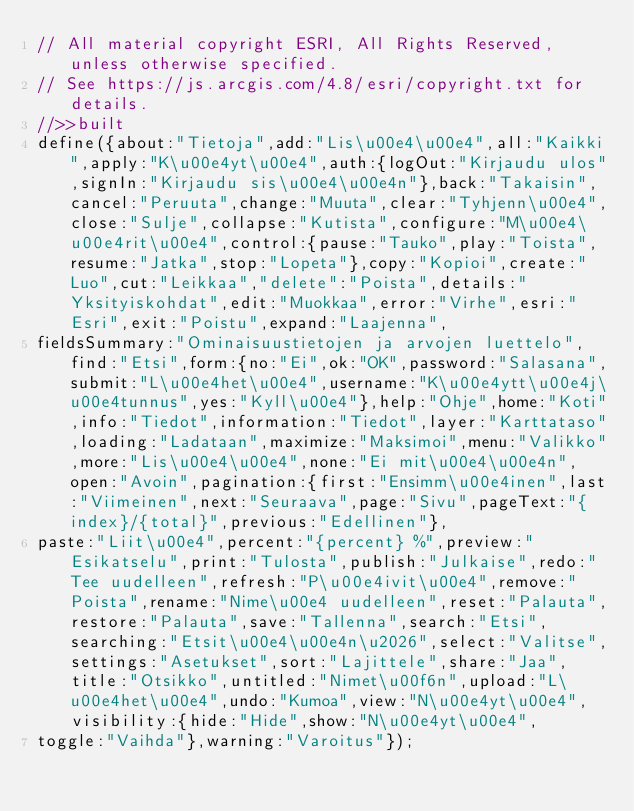<code> <loc_0><loc_0><loc_500><loc_500><_JavaScript_>// All material copyright ESRI, All Rights Reserved, unless otherwise specified.
// See https://js.arcgis.com/4.8/esri/copyright.txt for details.
//>>built
define({about:"Tietoja",add:"Lis\u00e4\u00e4",all:"Kaikki",apply:"K\u00e4yt\u00e4",auth:{logOut:"Kirjaudu ulos",signIn:"Kirjaudu sis\u00e4\u00e4n"},back:"Takaisin",cancel:"Peruuta",change:"Muuta",clear:"Tyhjenn\u00e4",close:"Sulje",collapse:"Kutista",configure:"M\u00e4\u00e4rit\u00e4",control:{pause:"Tauko",play:"Toista",resume:"Jatka",stop:"Lopeta"},copy:"Kopioi",create:"Luo",cut:"Leikkaa","delete":"Poista",details:"Yksityiskohdat",edit:"Muokkaa",error:"Virhe",esri:"Esri",exit:"Poistu",expand:"Laajenna",
fieldsSummary:"Ominaisuustietojen ja arvojen luettelo",find:"Etsi",form:{no:"Ei",ok:"OK",password:"Salasana",submit:"L\u00e4het\u00e4",username:"K\u00e4ytt\u00e4j\u00e4tunnus",yes:"Kyll\u00e4"},help:"Ohje",home:"Koti",info:"Tiedot",information:"Tiedot",layer:"Karttataso",loading:"Ladataan",maximize:"Maksimoi",menu:"Valikko",more:"Lis\u00e4\u00e4",none:"Ei mit\u00e4\u00e4n",open:"Avoin",pagination:{first:"Ensimm\u00e4inen",last:"Viimeinen",next:"Seuraava",page:"Sivu",pageText:"{index}/{total}",previous:"Edellinen"},
paste:"Liit\u00e4",percent:"{percent} %",preview:"Esikatselu",print:"Tulosta",publish:"Julkaise",redo:"Tee uudelleen",refresh:"P\u00e4ivit\u00e4",remove:"Poista",rename:"Nime\u00e4 uudelleen",reset:"Palauta",restore:"Palauta",save:"Tallenna",search:"Etsi",searching:"Etsit\u00e4\u00e4n\u2026",select:"Valitse",settings:"Asetukset",sort:"Lajittele",share:"Jaa",title:"Otsikko",untitled:"Nimet\u00f6n",upload:"L\u00e4het\u00e4",undo:"Kumoa",view:"N\u00e4yt\u00e4",visibility:{hide:"Hide",show:"N\u00e4yt\u00e4",
toggle:"Vaihda"},warning:"Varoitus"});</code> 